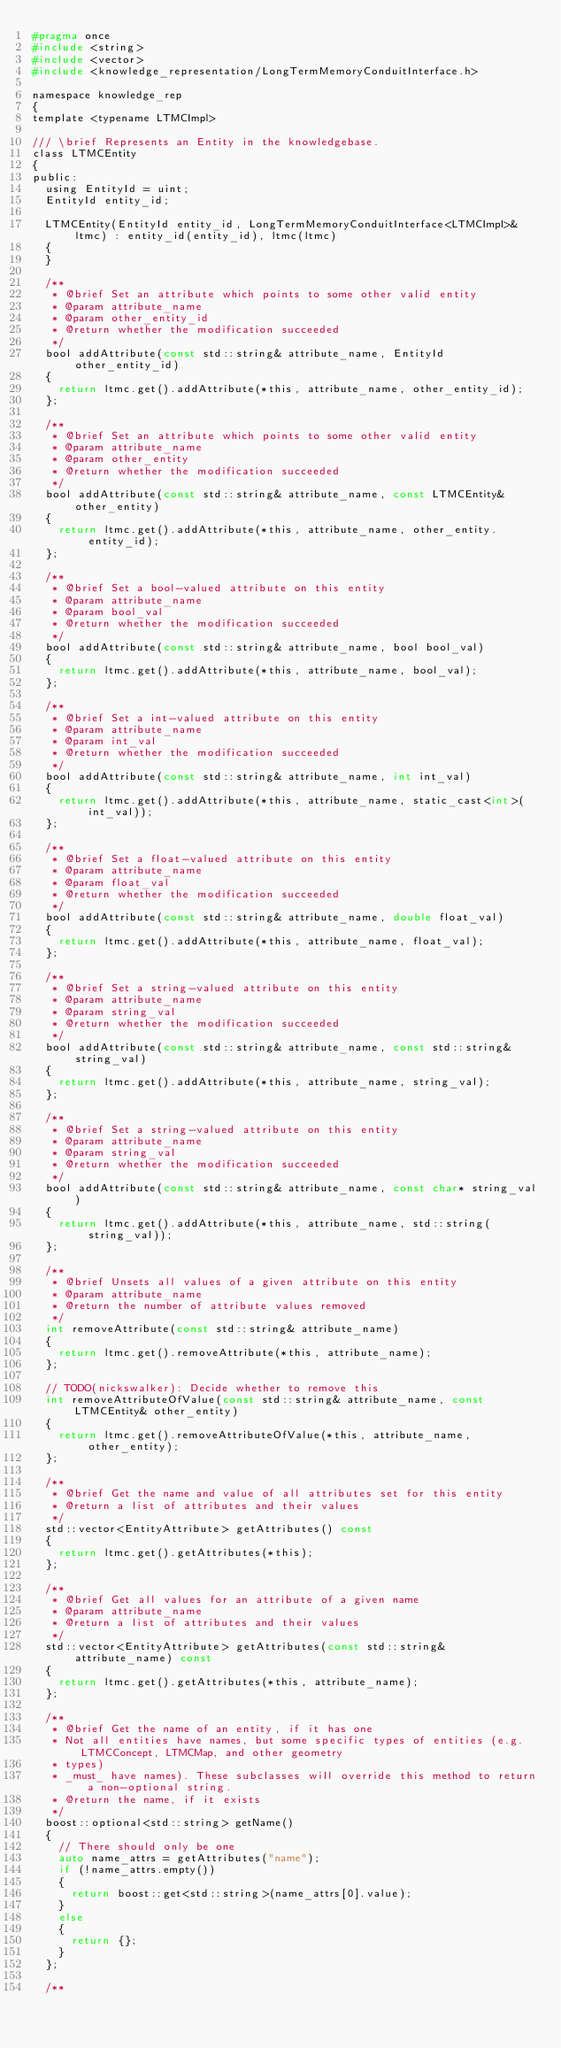Convert code to text. <code><loc_0><loc_0><loc_500><loc_500><_C_>#pragma once
#include <string>
#include <vector>
#include <knowledge_representation/LongTermMemoryConduitInterface.h>

namespace knowledge_rep
{
template <typename LTMCImpl>

/// \brief Represents an Entity in the knowledgebase.
class LTMCEntity
{
public:
  using EntityId = uint;
  EntityId entity_id;

  LTMCEntity(EntityId entity_id, LongTermMemoryConduitInterface<LTMCImpl>& ltmc) : entity_id(entity_id), ltmc(ltmc)
  {
  }

  /**
   * @brief Set an attribute which points to some other valid entity
   * @param attribute_name
   * @param other_entity_id
   * @return whether the modification succeeded
   */
  bool addAttribute(const std::string& attribute_name, EntityId other_entity_id)
  {
    return ltmc.get().addAttribute(*this, attribute_name, other_entity_id);
  };

  /**
   * @brief Set an attribute which points to some other valid entity
   * @param attribute_name
   * @param other_entity
   * @return whether the modification succeeded
   */
  bool addAttribute(const std::string& attribute_name, const LTMCEntity& other_entity)
  {
    return ltmc.get().addAttribute(*this, attribute_name, other_entity.entity_id);
  };

  /**
   * @brief Set a bool-valued attribute on this entity
   * @param attribute_name
   * @param bool_val
   * @return whether the modification succeeded
   */
  bool addAttribute(const std::string& attribute_name, bool bool_val)
  {
    return ltmc.get().addAttribute(*this, attribute_name, bool_val);
  };

  /**
   * @brief Set a int-valued attribute on this entity
   * @param attribute_name
   * @param int_val
   * @return whether the modification succeeded
   */
  bool addAttribute(const std::string& attribute_name, int int_val)
  {
    return ltmc.get().addAttribute(*this, attribute_name, static_cast<int>(int_val));
  };

  /**
   * @brief Set a float-valued attribute on this entity
   * @param attribute_name
   * @param float_val
   * @return whether the modification succeeded
   */
  bool addAttribute(const std::string& attribute_name, double float_val)
  {
    return ltmc.get().addAttribute(*this, attribute_name, float_val);
  };

  /**
   * @brief Set a string-valued attribute on this entity
   * @param attribute_name
   * @param string_val
   * @return whether the modification succeeded
   */
  bool addAttribute(const std::string& attribute_name, const std::string& string_val)
  {
    return ltmc.get().addAttribute(*this, attribute_name, string_val);
  };

  /**
   * @brief Set a string-valued attribute on this entity
   * @param attribute_name
   * @param string_val
   * @return whether the modification succeeded
   */
  bool addAttribute(const std::string& attribute_name, const char* string_val)
  {
    return ltmc.get().addAttribute(*this, attribute_name, std::string(string_val));
  };

  /**
   * @brief Unsets all values of a given attribute on this entity
   * @param attribute_name
   * @return the number of attribute values removed
   */
  int removeAttribute(const std::string& attribute_name)
  {
    return ltmc.get().removeAttribute(*this, attribute_name);
  };

  // TODO(nickswalker): Decide whether to remove this
  int removeAttributeOfValue(const std::string& attribute_name, const LTMCEntity& other_entity)
  {
    return ltmc.get().removeAttributeOfValue(*this, attribute_name, other_entity);
  };

  /**
   * @brief Get the name and value of all attributes set for this entity
   * @return a list of attributes and their values
   */
  std::vector<EntityAttribute> getAttributes() const
  {
    return ltmc.get().getAttributes(*this);
  };

  /**
   * @brief Get all values for an attribute of a given name
   * @param attribute_name
   * @return a list of attributes and their values
   */
  std::vector<EntityAttribute> getAttributes(const std::string& attribute_name) const
  {
    return ltmc.get().getAttributes(*this, attribute_name);
  };

  /**
   * @brief Get the name of an entity, if it has one
   * Not all entities have names, but some specific types of entities (e.g. LTMCConcept, LTMCMap, and other geometry
   * types)
   * _must_ have names). These subclasses will override this method to return a non-optional string.
   * @return the name, if it exists
   */
  boost::optional<std::string> getName()
  {
    // There should only be one
    auto name_attrs = getAttributes("name");
    if (!name_attrs.empty())
    {
      return boost::get<std::string>(name_attrs[0].value);
    }
    else
    {
      return {};
    }
  };

  /**</code> 